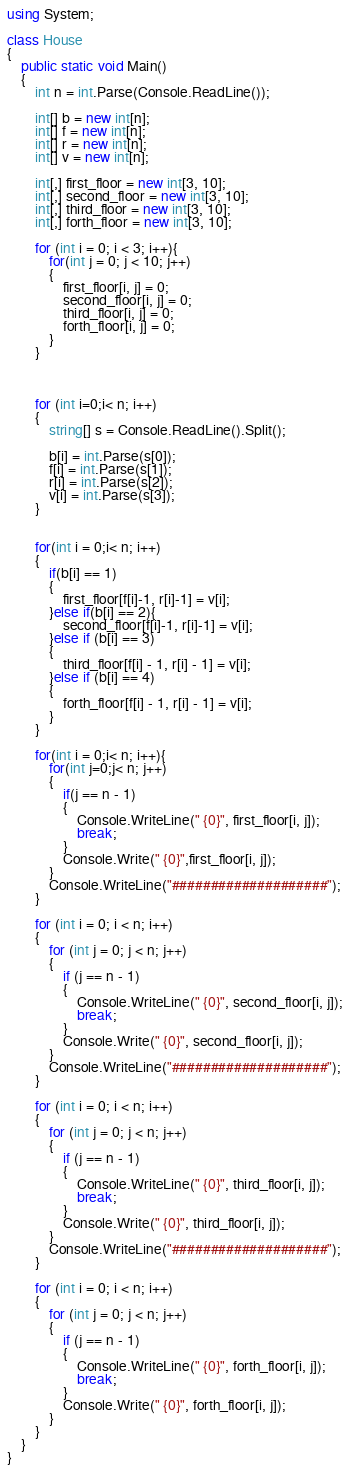<code> <loc_0><loc_0><loc_500><loc_500><_C#_>using System;

class House
{
    public static void Main()
    {
        int n = int.Parse(Console.ReadLine());

        int[] b = new int[n];
        int[] f = new int[n];
        int[] r = new int[n];
        int[] v = new int[n];

        int[,] first_floor = new int[3, 10];
        int[,] second_floor = new int[3, 10];
        int[,] third_floor = new int[3, 10];
        int[,] forth_floor = new int[3, 10];

        for (int i = 0; i < 3; i++){
            for(int j = 0; j < 10; j++)
            {
                first_floor[i, j] = 0;
                second_floor[i, j] = 0;
                third_floor[i, j] = 0;
                forth_floor[i, j] = 0;
            }
        }



        for (int i=0;i< n; i++)
        {
            string[] s = Console.ReadLine().Split();

            b[i] = int.Parse(s[0]);
            f[i] = int.Parse(s[1]);
            r[i] = int.Parse(s[2]);
            v[i] = int.Parse(s[3]);
        }


        for(int i = 0;i< n; i++)
        {
            if(b[i] == 1)
            {
                first_floor[f[i]-1, r[i]-1] = v[i];
            }else if(b[i] == 2){
                second_floor[f[i]-1, r[i]-1] = v[i];
            }else if (b[i] == 3)
            {
                third_floor[f[i] - 1, r[i] - 1] = v[i];
            }else if (b[i] == 4)
            {
                forth_floor[f[i] - 1, r[i] - 1] = v[i];
            }
        }

        for(int i = 0;i< n; i++){
            for(int j=0;j< n; j++)
            {
                if(j == n - 1)
                {
                    Console.WriteLine(" {0}", first_floor[i, j]);
                    break;
                }
                Console.Write(" {0}",first_floor[i, j]);
            }
            Console.WriteLine("####################");
        }

        for (int i = 0; i < n; i++)
        {
            for (int j = 0; j < n; j++)
            {
                if (j == n - 1)
                {
                    Console.WriteLine(" {0}", second_floor[i, j]);
                    break;
                }
                Console.Write(" {0}", second_floor[i, j]);
            }
            Console.WriteLine("####################");
        }

        for (int i = 0; i < n; i++)
        {
            for (int j = 0; j < n; j++)
            {
                if (j == n - 1)
                {
                    Console.WriteLine(" {0}", third_floor[i, j]);
                    break;
                }
                Console.Write(" {0}", third_floor[i, j]);
            }
            Console.WriteLine("####################");
        }

        for (int i = 0; i < n; i++)
        {
            for (int j = 0; j < n; j++)
            {
                if (j == n - 1)
                {
                    Console.WriteLine(" {0}", forth_floor[i, j]);
                    break;
                }
                Console.Write(" {0}", forth_floor[i, j]);
            }
        }
    }
}
</code> 